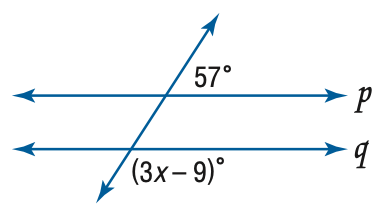Question: Find x so that p \parallel q.
Choices:
A. 16
B. 22
C. 44
D. 66
Answer with the letter. Answer: C 